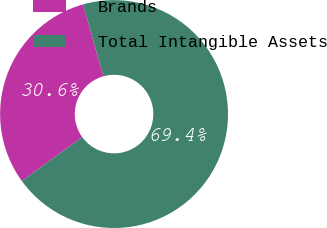Convert chart to OTSL. <chart><loc_0><loc_0><loc_500><loc_500><pie_chart><fcel>Brands<fcel>Total Intangible Assets<nl><fcel>30.62%<fcel>69.38%<nl></chart> 